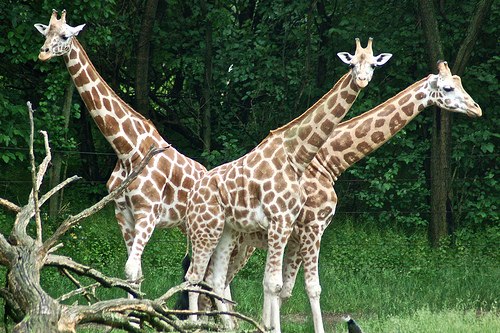<image>
Is the giraffe behind the tree? Yes. From this viewpoint, the giraffe is positioned behind the tree, with the tree partially or fully occluding the giraffe. Where is the spot in relation to the giraffe? Is it behind the giraffe? No. The spot is not behind the giraffe. From this viewpoint, the spot appears to be positioned elsewhere in the scene. 